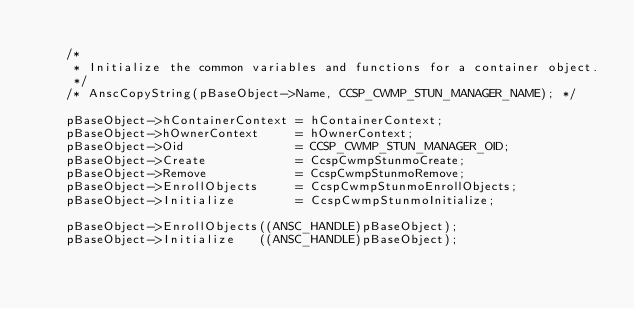Convert code to text. <code><loc_0><loc_0><loc_500><loc_500><_C_>
    /*
     * Initialize the common variables and functions for a container object.
     */
    /* AnscCopyString(pBaseObject->Name, CCSP_CWMP_STUN_MANAGER_NAME); */

    pBaseObject->hContainerContext = hContainerContext;
    pBaseObject->hOwnerContext     = hOwnerContext;
    pBaseObject->Oid               = CCSP_CWMP_STUN_MANAGER_OID;
    pBaseObject->Create            = CcspCwmpStunmoCreate;
    pBaseObject->Remove            = CcspCwmpStunmoRemove;
    pBaseObject->EnrollObjects     = CcspCwmpStunmoEnrollObjects;
    pBaseObject->Initialize        = CcspCwmpStunmoInitialize;

    pBaseObject->EnrollObjects((ANSC_HANDLE)pBaseObject);
    pBaseObject->Initialize   ((ANSC_HANDLE)pBaseObject);
</code> 